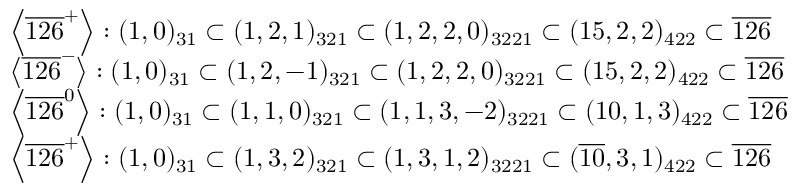<formula> <loc_0><loc_0><loc_500><loc_500>\begin{array} { l } { { \left < \overline { 1 2 6 } ^ { + } \right > \colon ( 1 , 0 ) _ { 3 1 } \subset ( 1 , 2 , 1 ) _ { 3 2 1 } \subset ( 1 , 2 , 2 , 0 ) _ { 3 2 2 1 } \subset ( 1 5 , 2 , 2 ) _ { 4 2 2 } \subset \overline { 1 2 6 } } } \\ { { \left < \overline { 1 2 6 } ^ { - } \right > \colon ( 1 , 0 ) _ { 3 1 } \subset ( 1 , 2 , - 1 ) _ { 3 2 1 } \subset ( 1 , 2 , 2 , 0 ) _ { 3 2 2 1 } \subset ( 1 5 , 2 , 2 ) _ { 4 2 2 } \subset \overline { 1 2 6 } } } \\ { { \left < \overline { 1 2 6 } ^ { 0 } \right > \colon ( 1 , 0 ) _ { 3 1 } \subset ( 1 , 1 , 0 ) _ { 3 2 1 } \subset ( 1 , 1 , 3 , - 2 ) _ { 3 2 2 1 } \subset ( 1 0 , 1 , 3 ) _ { 4 2 2 } \subset \overline { 1 2 6 } } } \\ { { \left < \overline { 1 2 6 } ^ { + } \right > \colon ( 1 , 0 ) _ { 3 1 } \subset ( 1 , 3 , 2 ) _ { 3 2 1 } \subset ( 1 , 3 , 1 , 2 ) _ { 3 2 2 1 } \subset ( \overline { 1 0 } , 3 , 1 ) _ { 4 2 2 } \subset \overline { 1 2 6 } } } \end{array}</formula> 